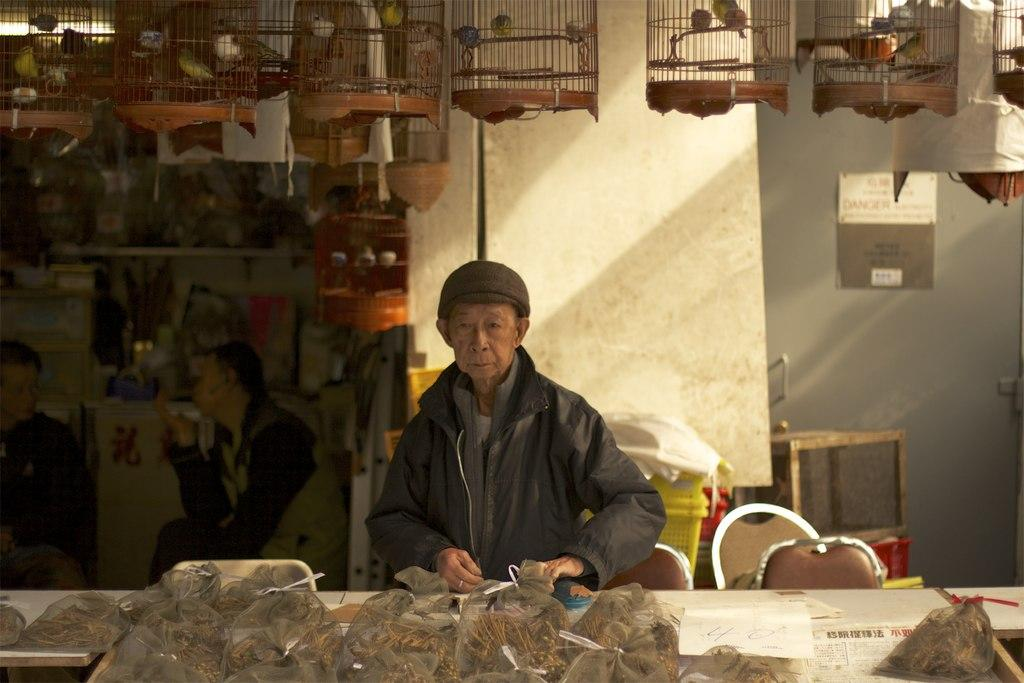What are the people in the image wearing? The people in the image are wearing clothes. Can you describe the headwear of one of the individuals? One person is wearing a cap. What type of furniture is present in the image? There are chairs in the image. What items can be seen on the shelf? The provided facts do not mention any items on the shelf. What is inside the cage in the image? There are birds in the cage. What is the background of the image made of? There is a wall in the image. What type of bags are visible in the image? There are bags in the image. How does the heat affect the people in the image? The provided facts do not mention any heat or temperature-related information. What message do the people in the image convey when saying good-bye? The provided facts do not mention any interactions or conversations between the people in the image. 